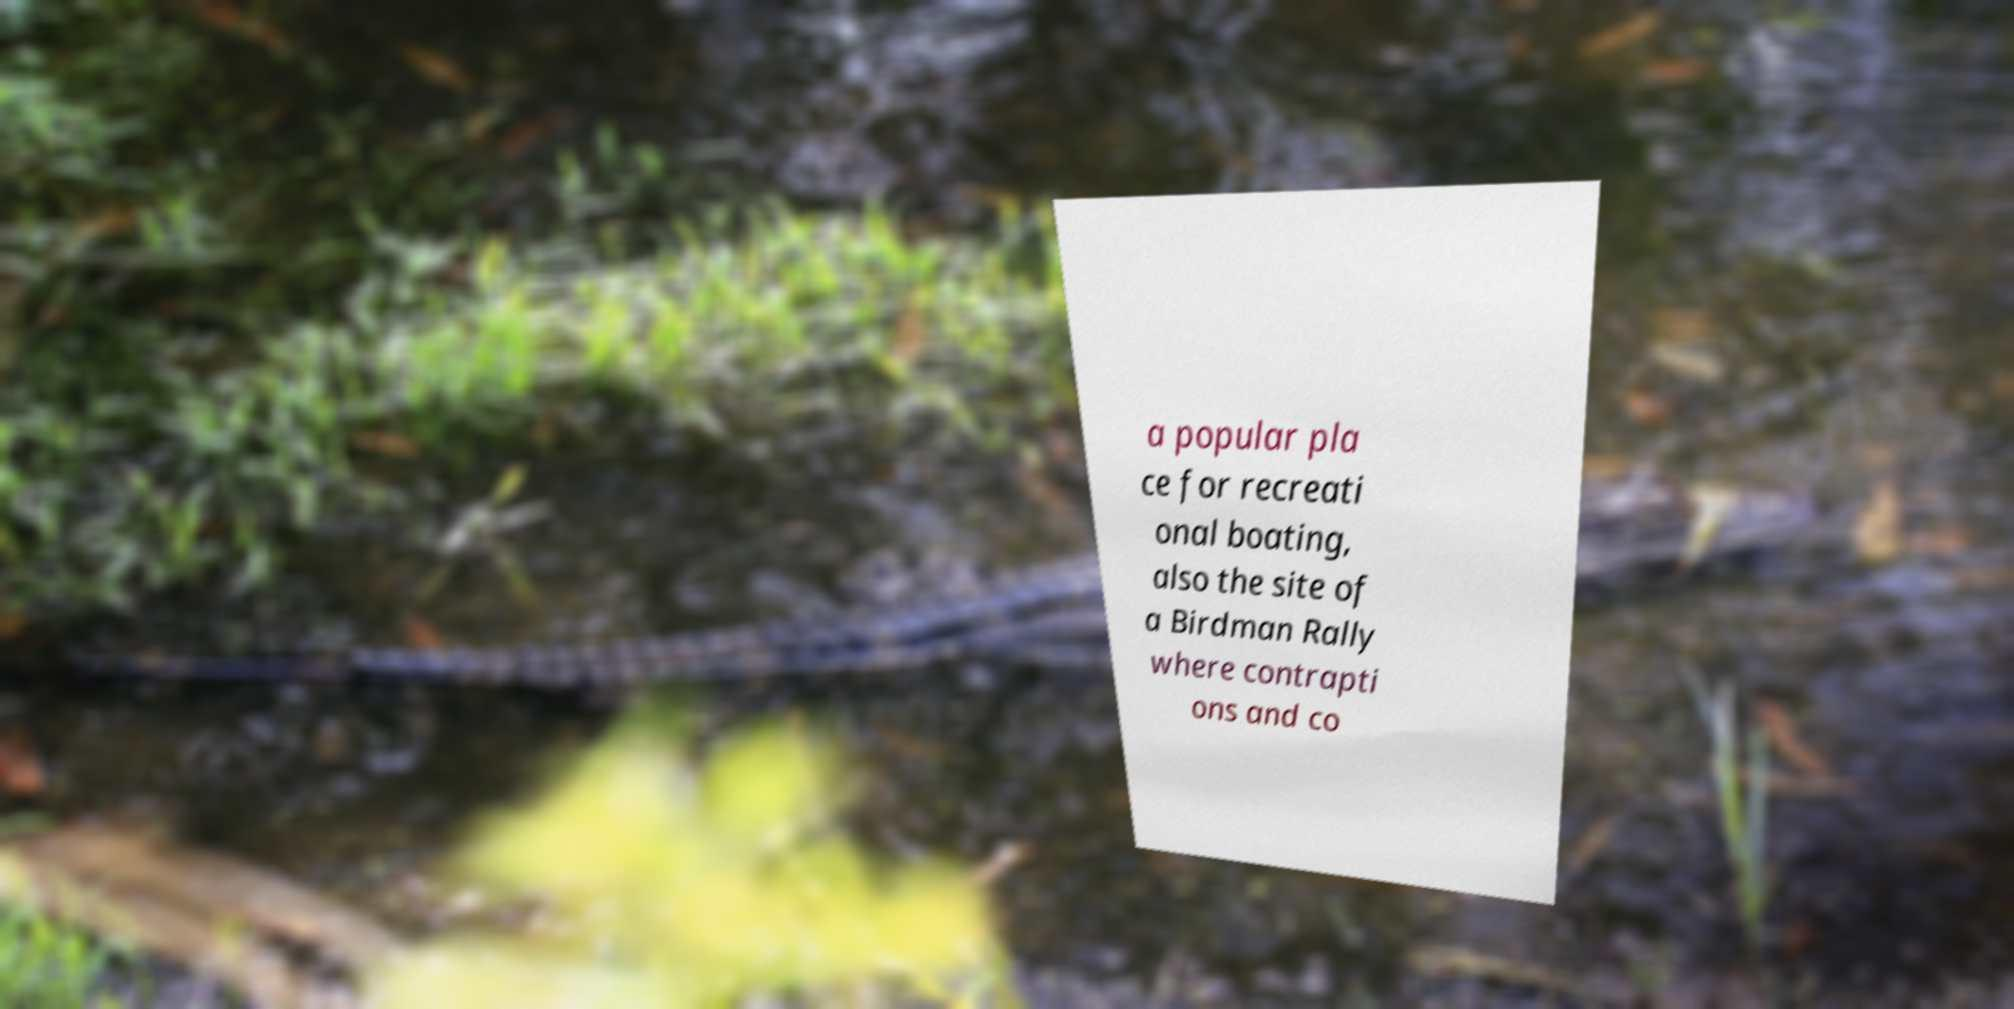Could you assist in decoding the text presented in this image and type it out clearly? a popular pla ce for recreati onal boating, also the site of a Birdman Rally where contrapti ons and co 